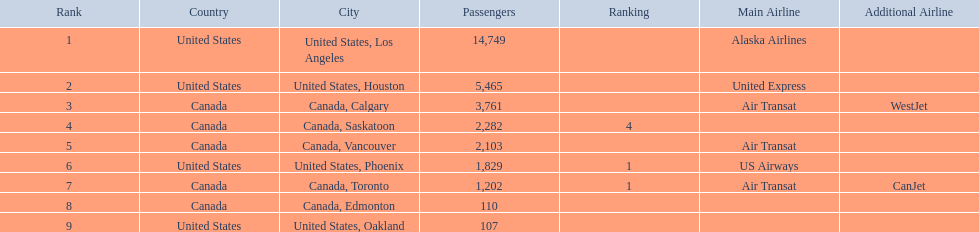Where are the destinations of the airport? United States, Los Angeles, United States, Houston, Canada, Calgary, Canada, Saskatoon, Canada, Vancouver, United States, Phoenix, Canada, Toronto, Canada, Edmonton, United States, Oakland. What is the number of passengers to phoenix? 1,829. 